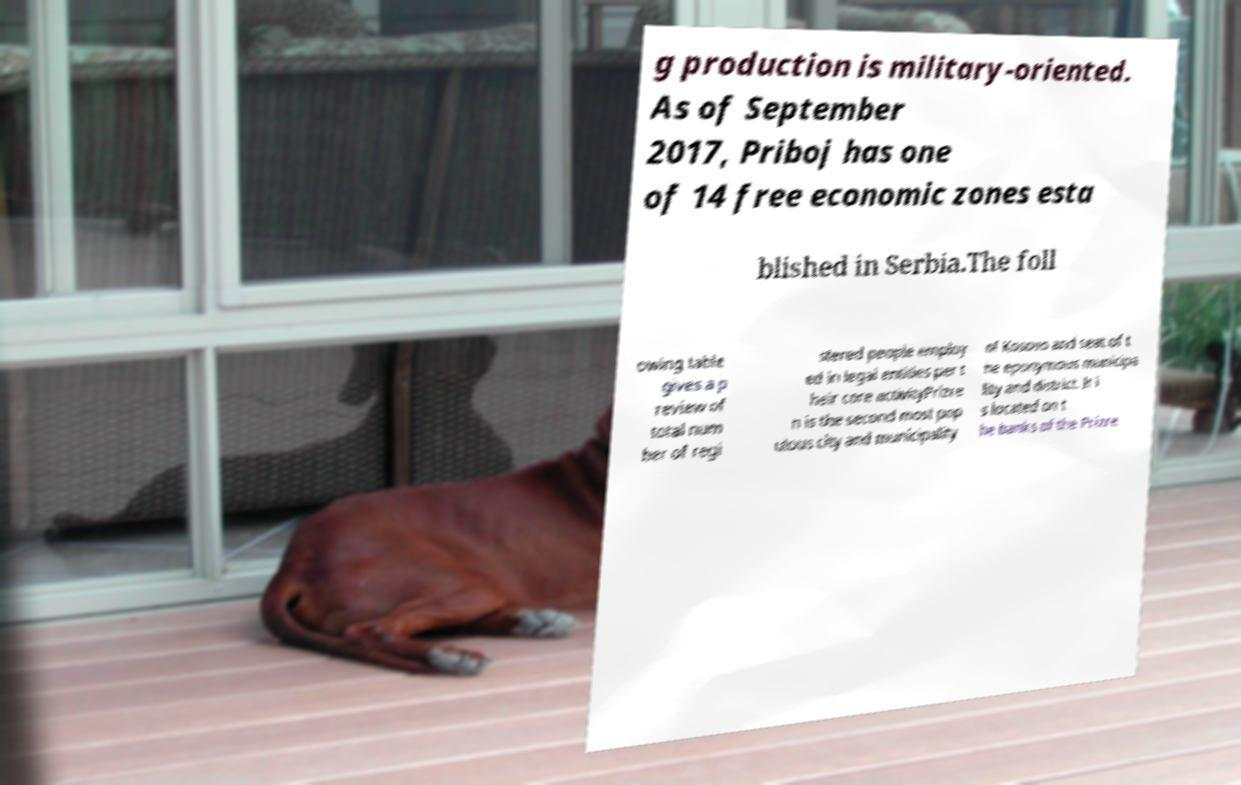Please identify and transcribe the text found in this image. g production is military-oriented. As of September 2017, Priboj has one of 14 free economic zones esta blished in Serbia.The foll owing table gives a p review of total num ber of regi stered people employ ed in legal entities per t heir core activityPrizre n is the second most pop ulous city and municipality of Kosovo and seat of t he eponymous municipa lity and district. It i s located on t he banks of the Prizre 